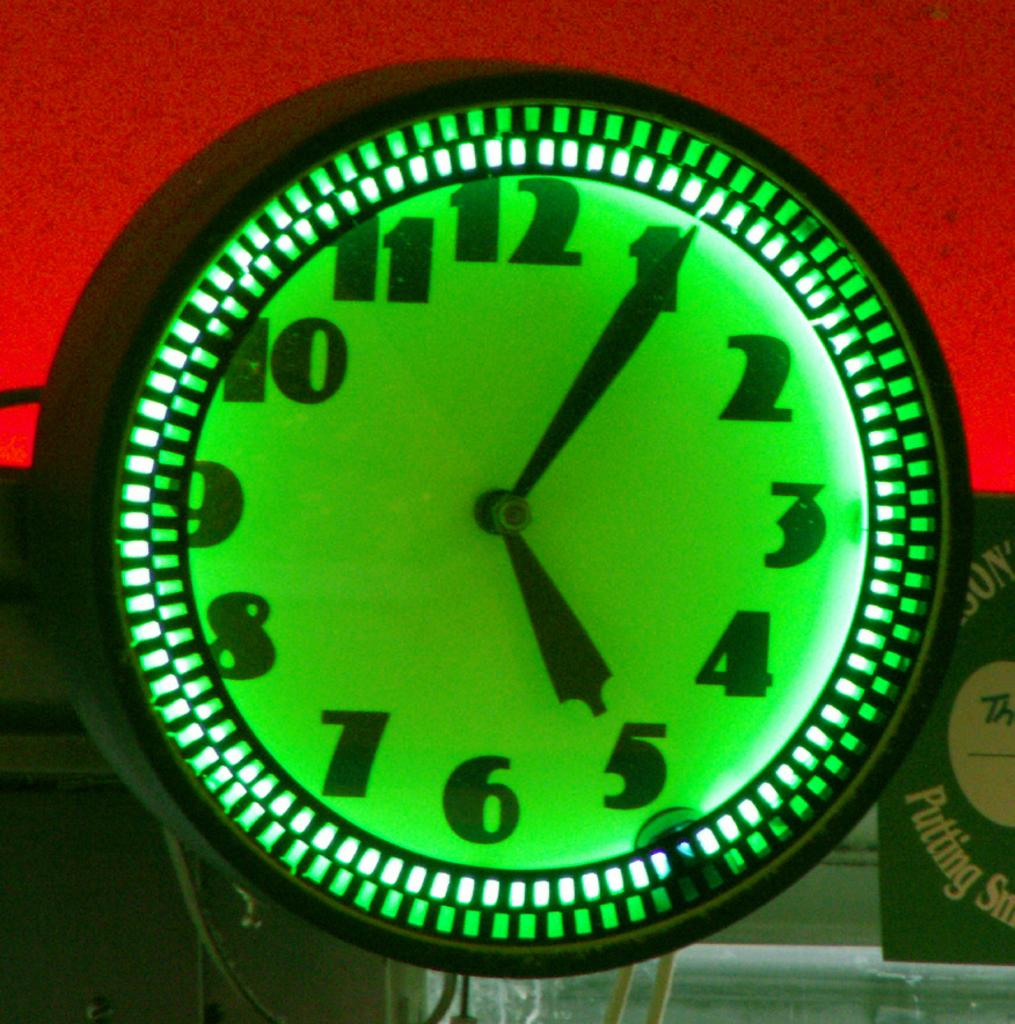<image>
Render a clear and concise summary of the photo. A green clock displays the time of 5:05, with a sign behind it that partially reads "putting." 